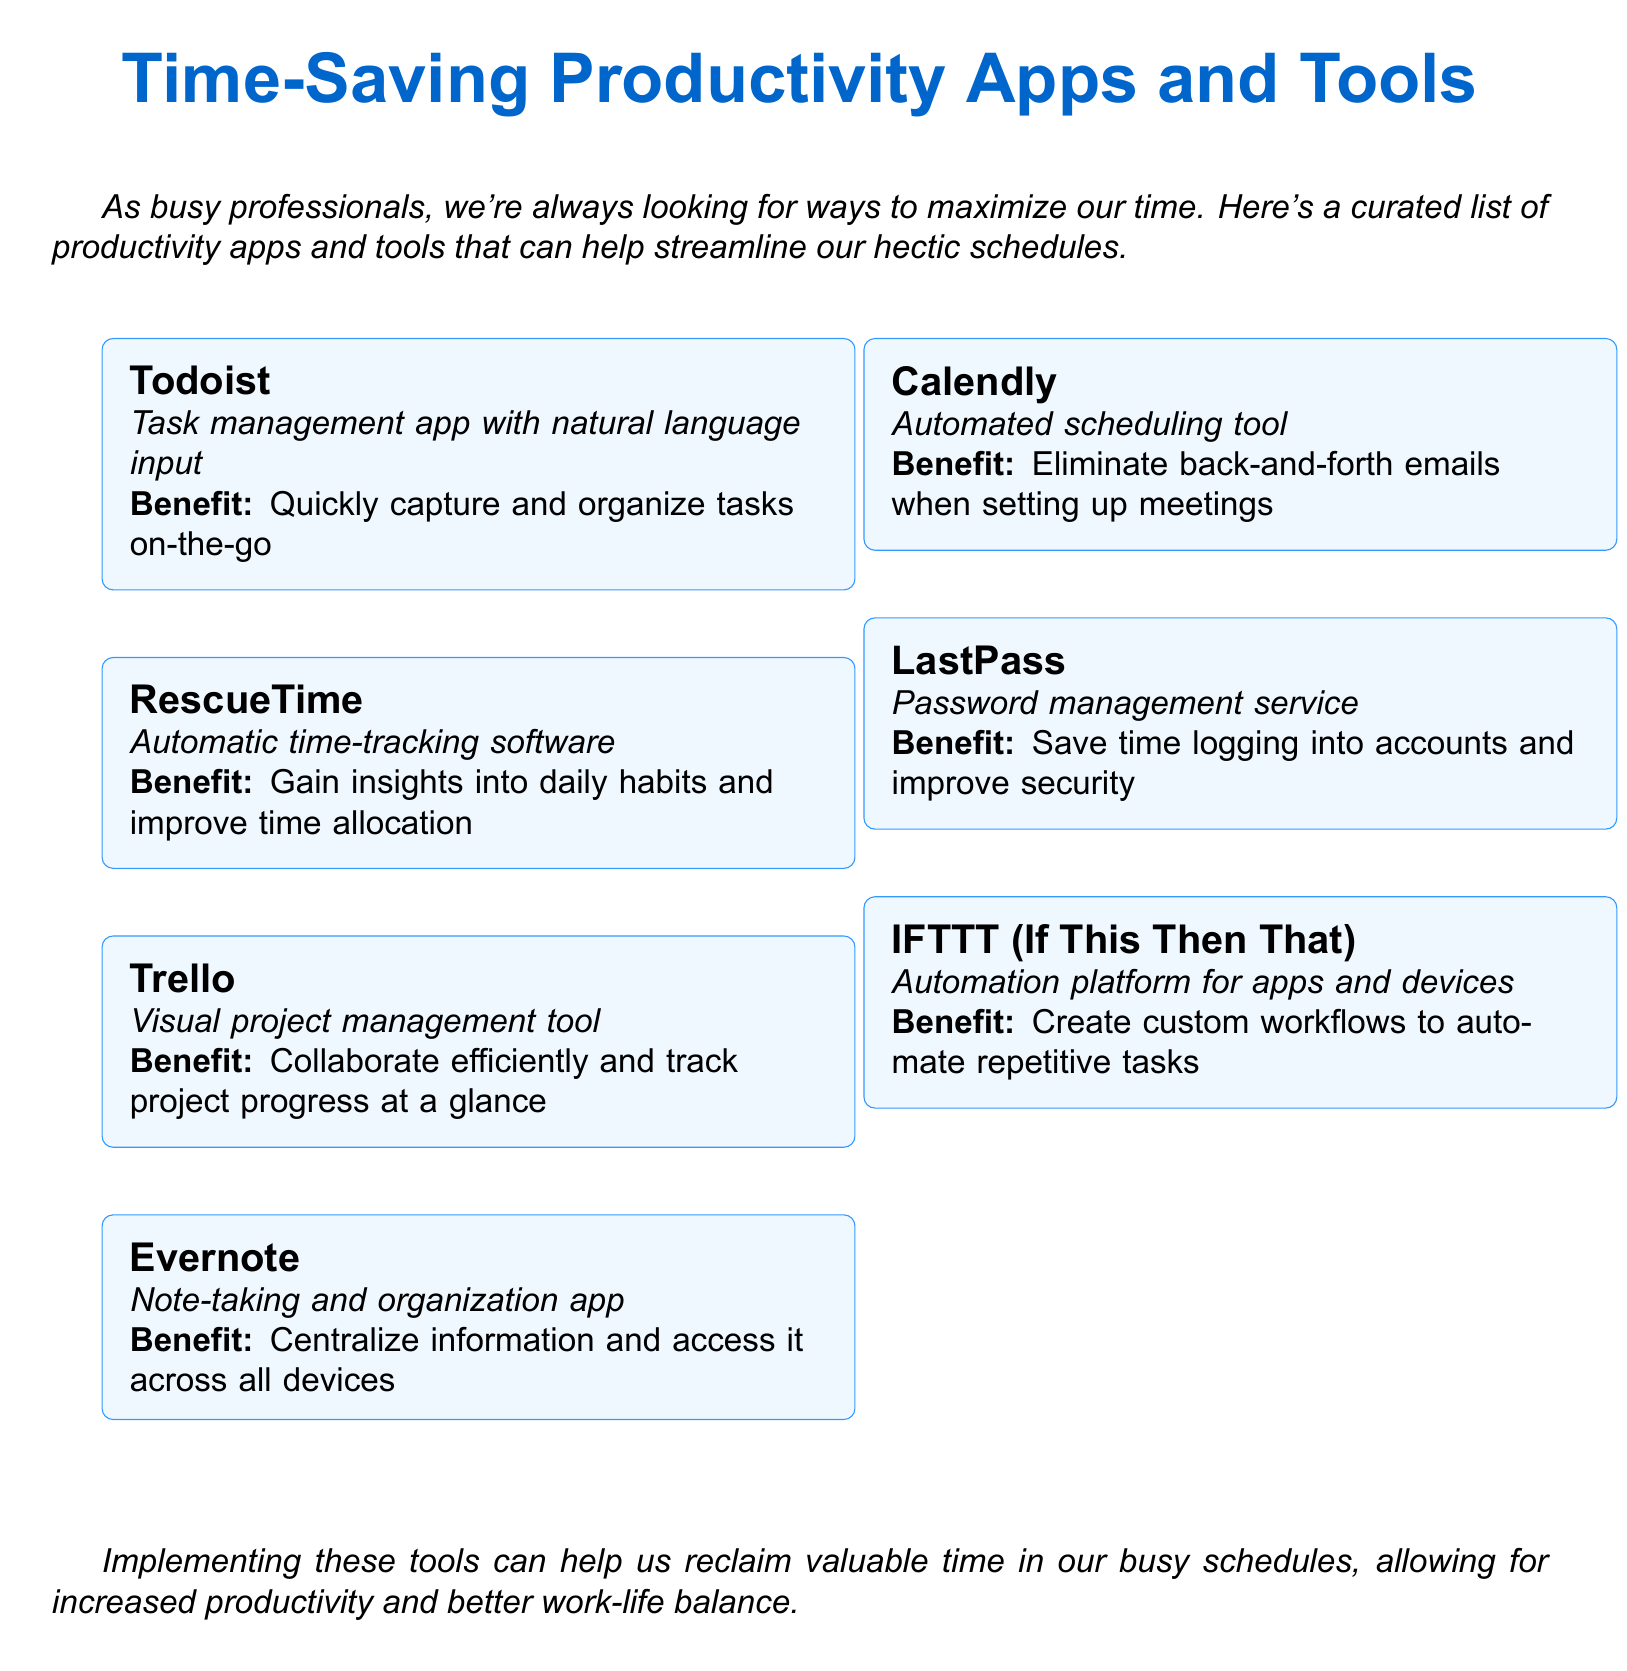What is the title of the document? The title is the main heading and gives a clear indication of the document's content.
Answer: Time-Saving Productivity Apps and Tools for Busy Professionals How many productivity apps are listed in the document? The document provides a total count of the apps mentioned.
Answer: Seven What is the benefit of using Todoist? The benefit provides a practical reason for utilizing Todoist based on its features.
Answer: Quickly capture and organize tasks on-the-go What type of tool is Calendly? Identifying the type of tool explains its primary function in the context of productivity.
Answer: Automated scheduling tool What does LastPass improve? This question examines the focus of LastPass in terms of user experience and security.
Answer: Security Which app allows for collaboration on projects? This question relates to features that facilitate teamwork and project management.
Answer: Trello What is the main purpose of RescueTime? Understanding the main purpose helps explain how it contributes to productivity.
Answer: Automatic time-tracking software What overall benefit do these tools provide? This question asks for the primary outcome of using the listed tools for busy professionals.
Answer: Increased productivity and better work-life balance 